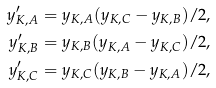Convert formula to latex. <formula><loc_0><loc_0><loc_500><loc_500>y _ { K , A } ^ { \prime } & = y _ { K , A } ( y _ { K , C } - y _ { K , B } ) / 2 , \\ y _ { K , B } ^ { \prime } & = y _ { K , B } ( y _ { K , A } - y _ { K , C } ) / 2 , \\ y _ { K , C } ^ { \prime } & = y _ { K , C } ( y _ { K , B } - y _ { K , A } ) / 2 ,</formula> 